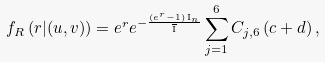Convert formula to latex. <formula><loc_0><loc_0><loc_500><loc_500>f _ { R } \left ( r | ( u , v ) \right ) = e ^ { r } e ^ { - \frac { ( e ^ { r } - 1 ) \, \text {I} _ { n } } { \overline { \text {I} } } } \sum _ { j = 1 } ^ { 6 } C _ { j , 6 } \left ( c + d \right ) ,</formula> 